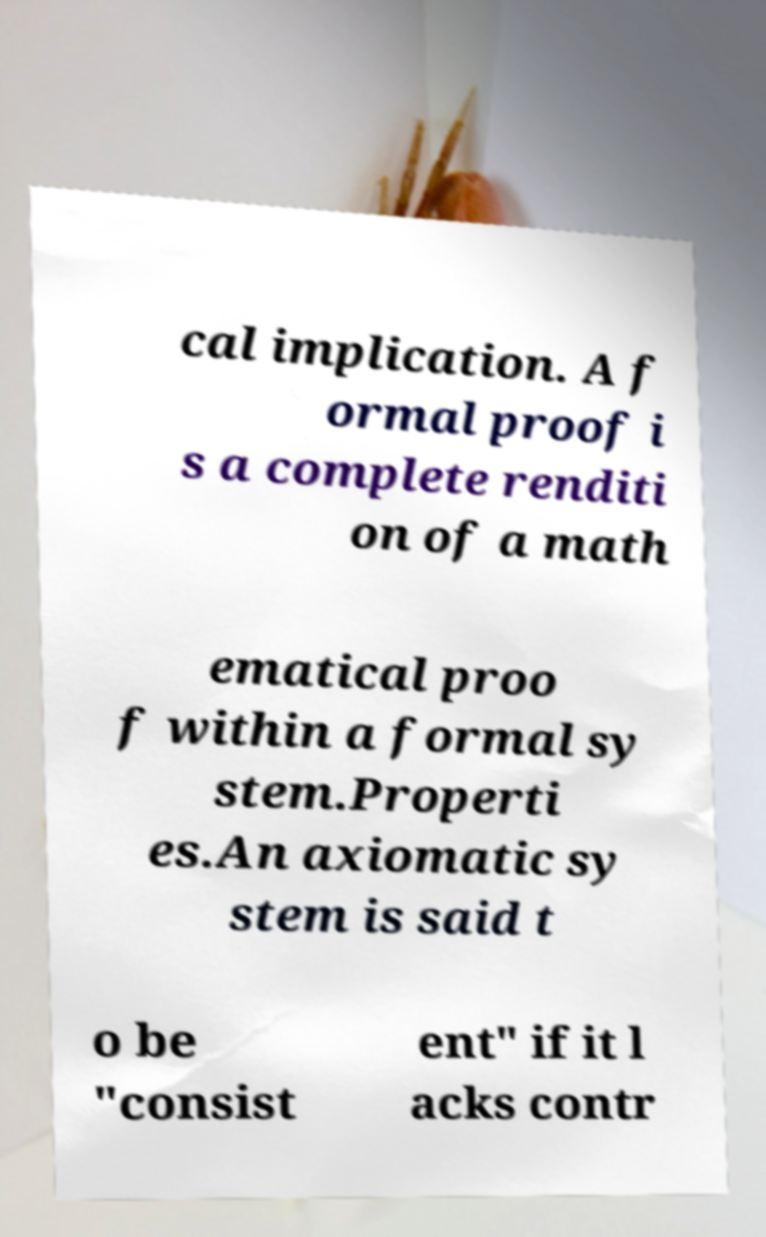What messages or text are displayed in this image? I need them in a readable, typed format. cal implication. A f ormal proof i s a complete renditi on of a math ematical proo f within a formal sy stem.Properti es.An axiomatic sy stem is said t o be "consist ent" if it l acks contr 